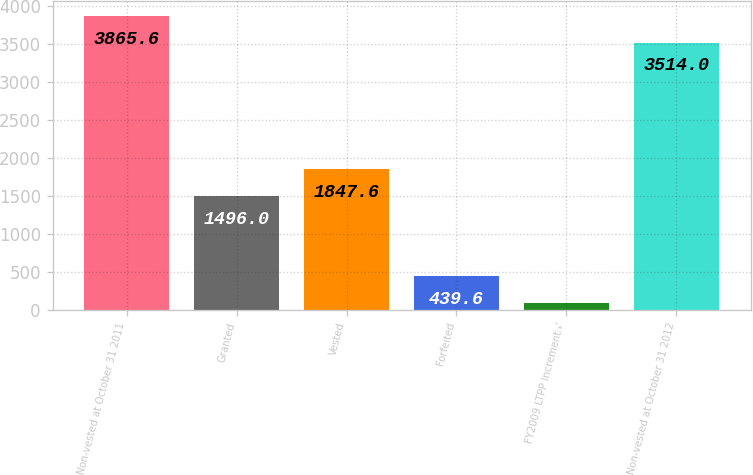Convert chart. <chart><loc_0><loc_0><loc_500><loc_500><bar_chart><fcel>Non-vested at October 31 2011<fcel>Granted<fcel>Vested<fcel>Forfeited<fcel>FY2009 LTPP Incremental<fcel>Non-vested at October 31 2012<nl><fcel>3865.6<fcel>1496<fcel>1847.6<fcel>439.6<fcel>88<fcel>3514<nl></chart> 